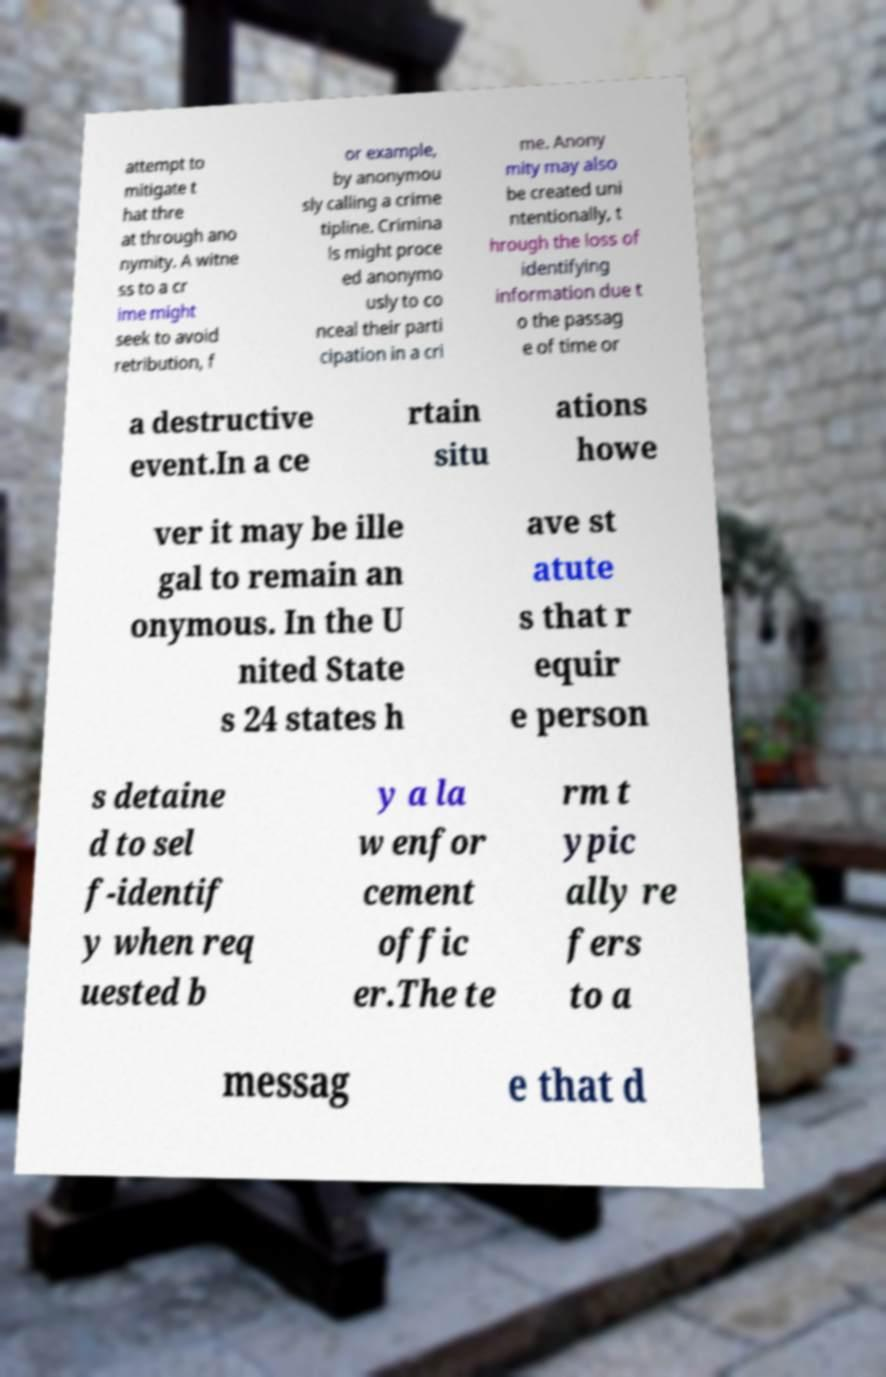Could you extract and type out the text from this image? attempt to mitigate t hat thre at through ano nymity. A witne ss to a cr ime might seek to avoid retribution, f or example, by anonymou sly calling a crime tipline. Crimina ls might proce ed anonymo usly to co nceal their parti cipation in a cri me. Anony mity may also be created uni ntentionally, t hrough the loss of identifying information due t o the passag e of time or a destructive event.In a ce rtain situ ations howe ver it may be ille gal to remain an onymous. In the U nited State s 24 states h ave st atute s that r equir e person s detaine d to sel f-identif y when req uested b y a la w enfor cement offic er.The te rm t ypic ally re fers to a messag e that d 